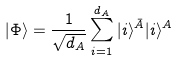Convert formula to latex. <formula><loc_0><loc_0><loc_500><loc_500>| \Phi \rangle = \frac { 1 } { \sqrt { d _ { A } } } \sum _ { i = 1 } ^ { d _ { A } } | i \rangle ^ { \bar { A } } | i \rangle ^ { A }</formula> 